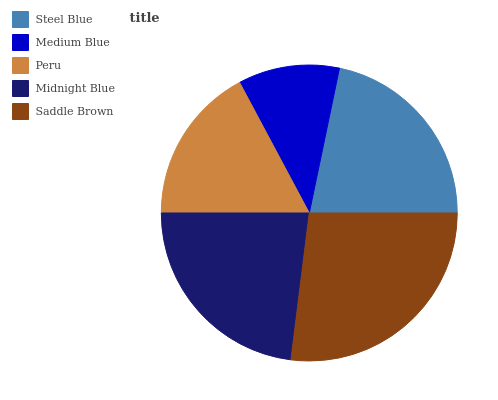Is Medium Blue the minimum?
Answer yes or no. Yes. Is Saddle Brown the maximum?
Answer yes or no. Yes. Is Peru the minimum?
Answer yes or no. No. Is Peru the maximum?
Answer yes or no. No. Is Peru greater than Medium Blue?
Answer yes or no. Yes. Is Medium Blue less than Peru?
Answer yes or no. Yes. Is Medium Blue greater than Peru?
Answer yes or no. No. Is Peru less than Medium Blue?
Answer yes or no. No. Is Steel Blue the high median?
Answer yes or no. Yes. Is Steel Blue the low median?
Answer yes or no. Yes. Is Medium Blue the high median?
Answer yes or no. No. Is Midnight Blue the low median?
Answer yes or no. No. 